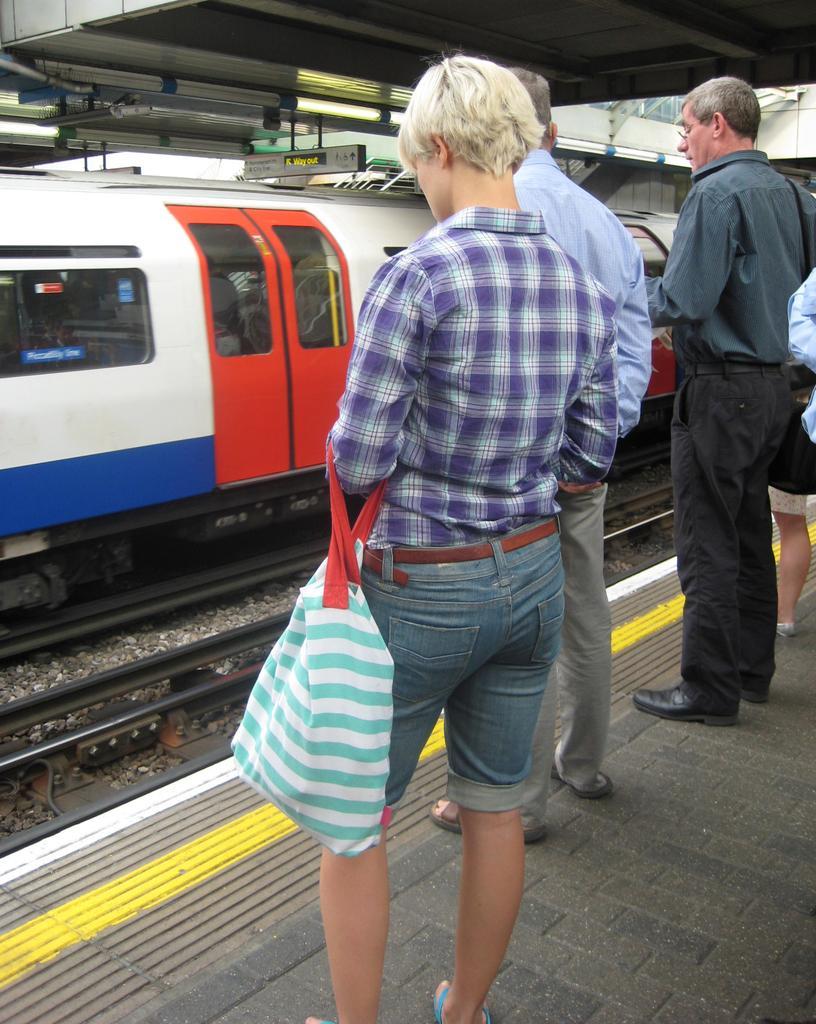In one or two sentences, can you explain what this image depicts? In this image we can see people standing. The person standing in the center is holding a bag. In the background we can see a train on the track. At the bottom there is a platform. 